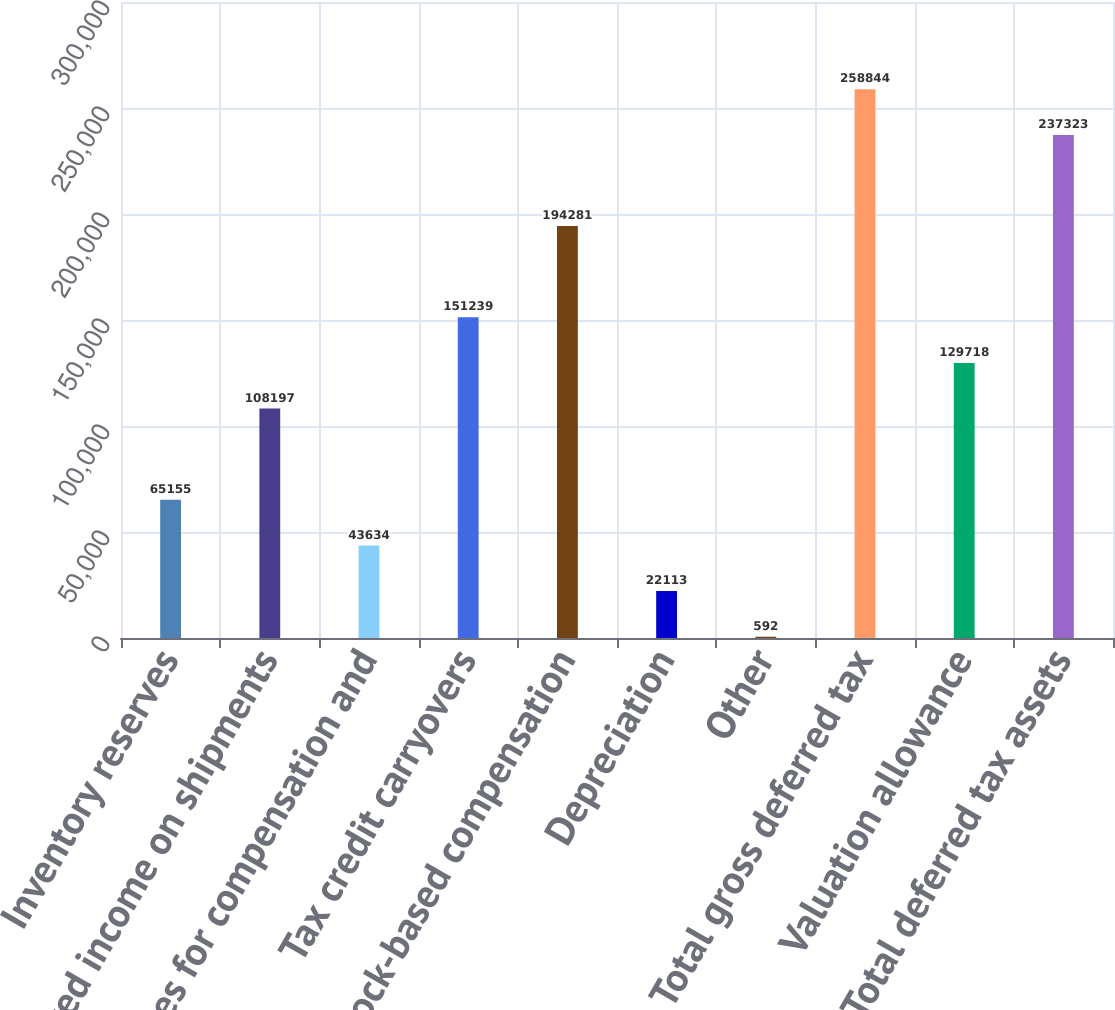Convert chart to OTSL. <chart><loc_0><loc_0><loc_500><loc_500><bar_chart><fcel>Inventory reserves<fcel>Deferred income on shipments<fcel>Reserves for compensation and<fcel>Tax credit carryovers<fcel>Stock-based compensation<fcel>Depreciation<fcel>Other<fcel>Total gross deferred tax<fcel>Valuation allowance<fcel>Total deferred tax assets<nl><fcel>65155<fcel>108197<fcel>43634<fcel>151239<fcel>194281<fcel>22113<fcel>592<fcel>258844<fcel>129718<fcel>237323<nl></chart> 